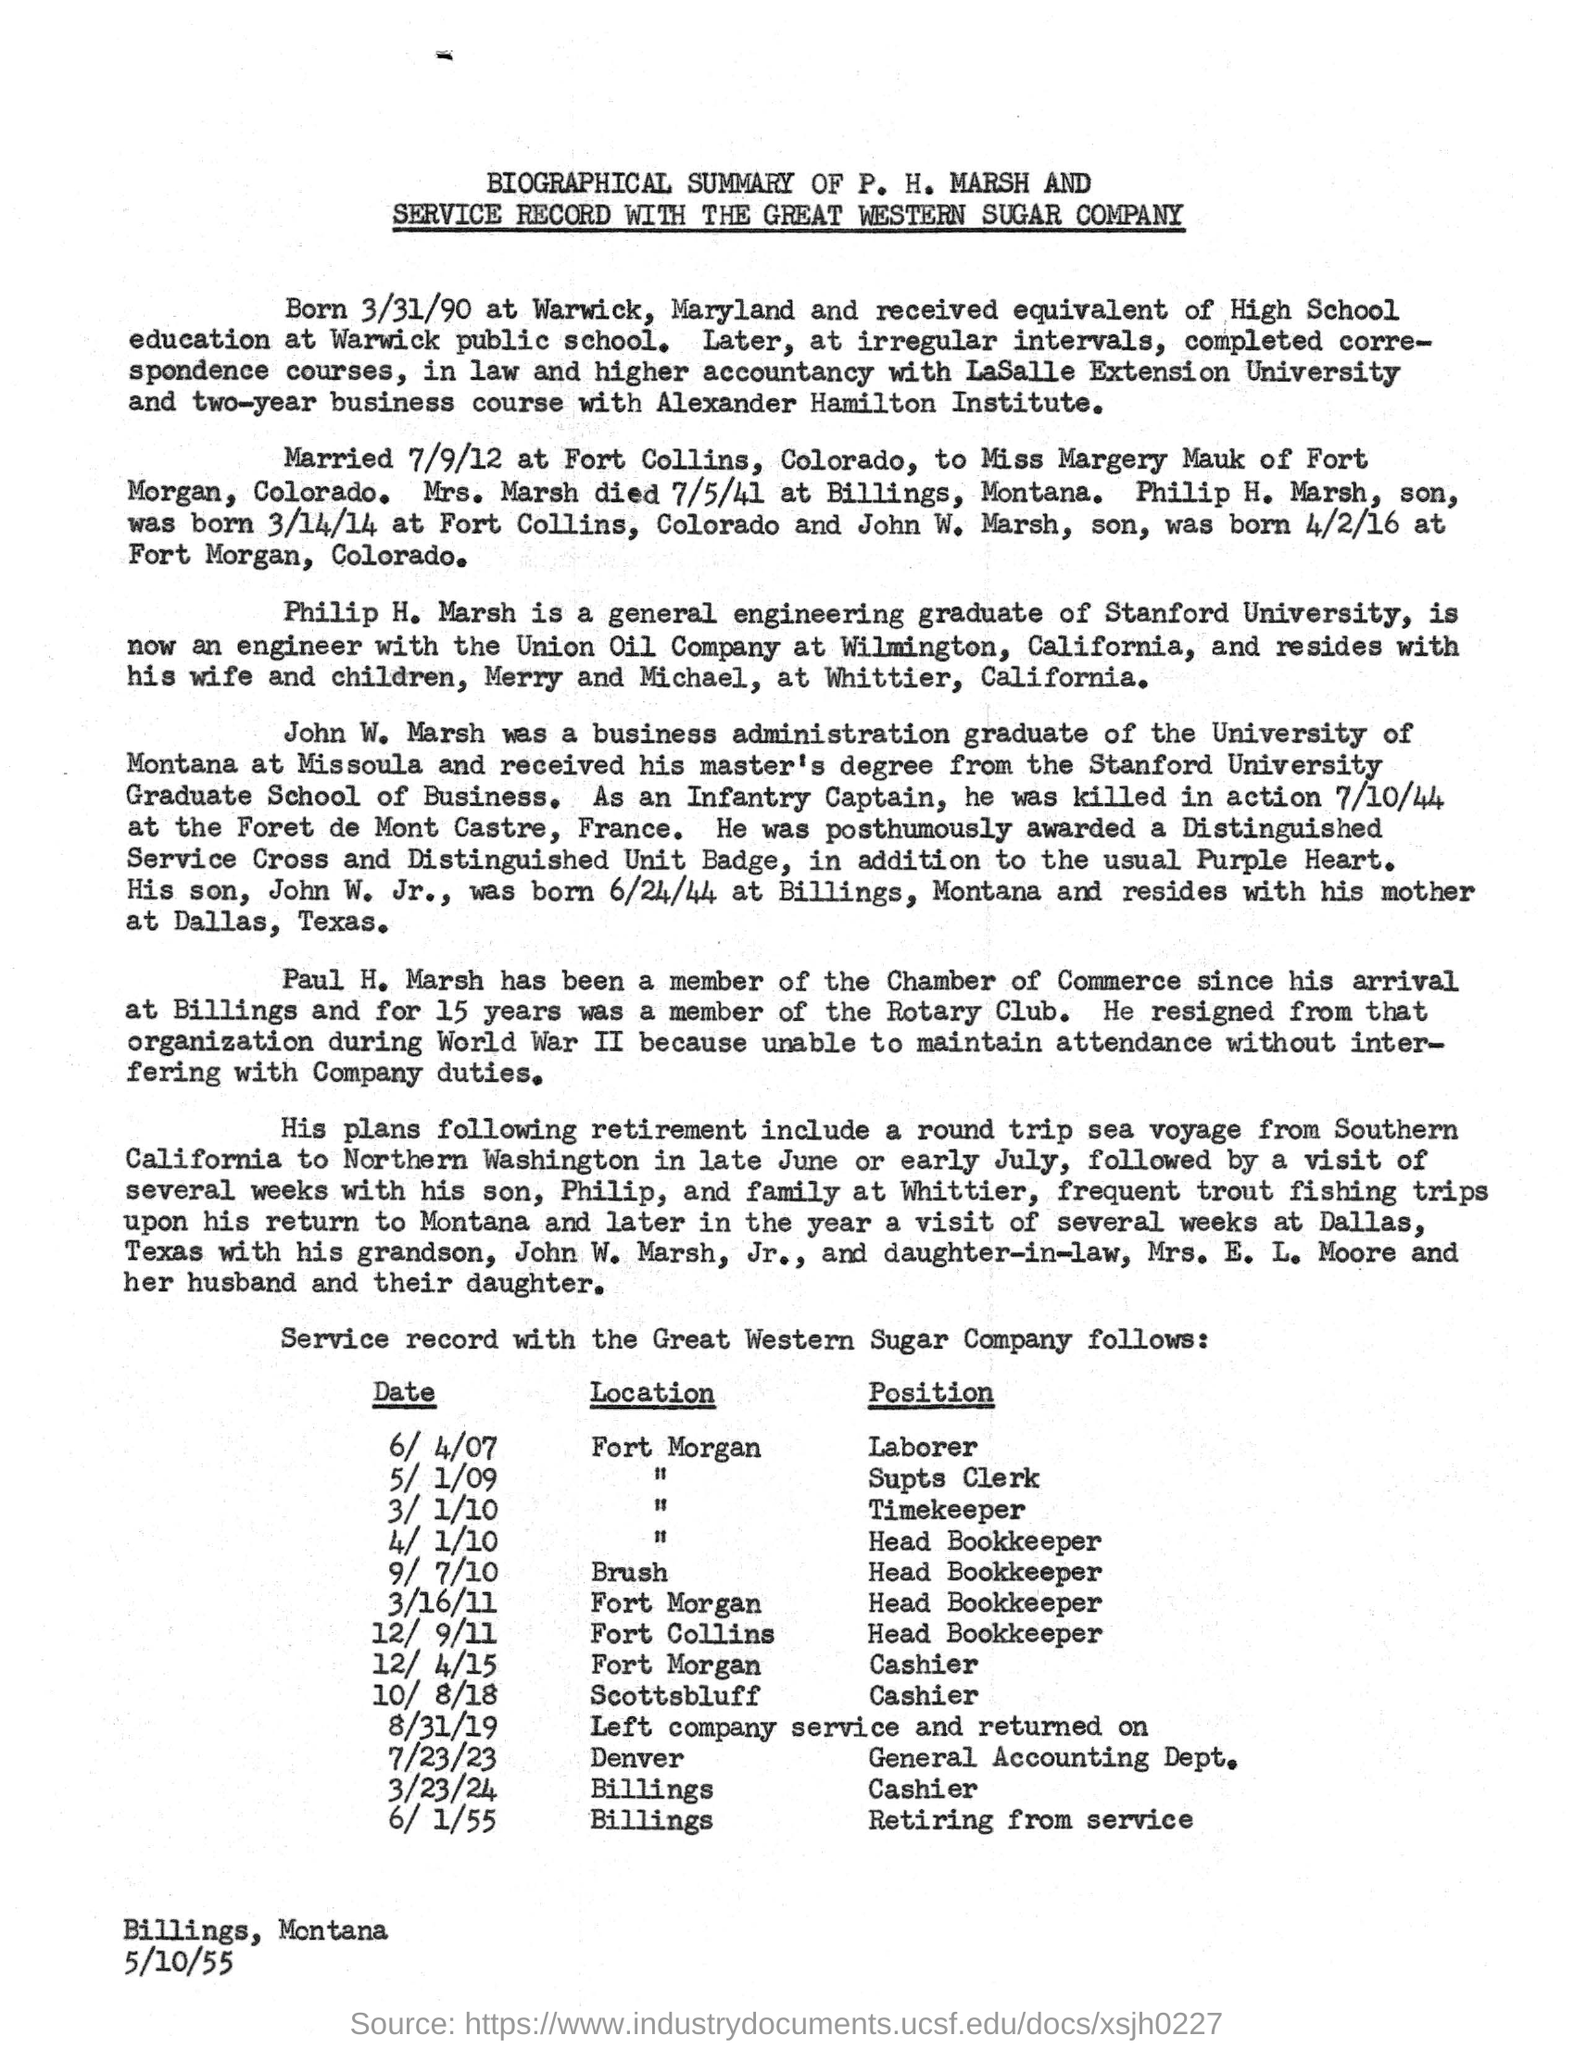To whom is P. H. MARSH married?
Your response must be concise. Miss Margery Mauk of Fort Morgan, Colorado. When is the document dated?
Your answer should be very brief. 5/10/55. 